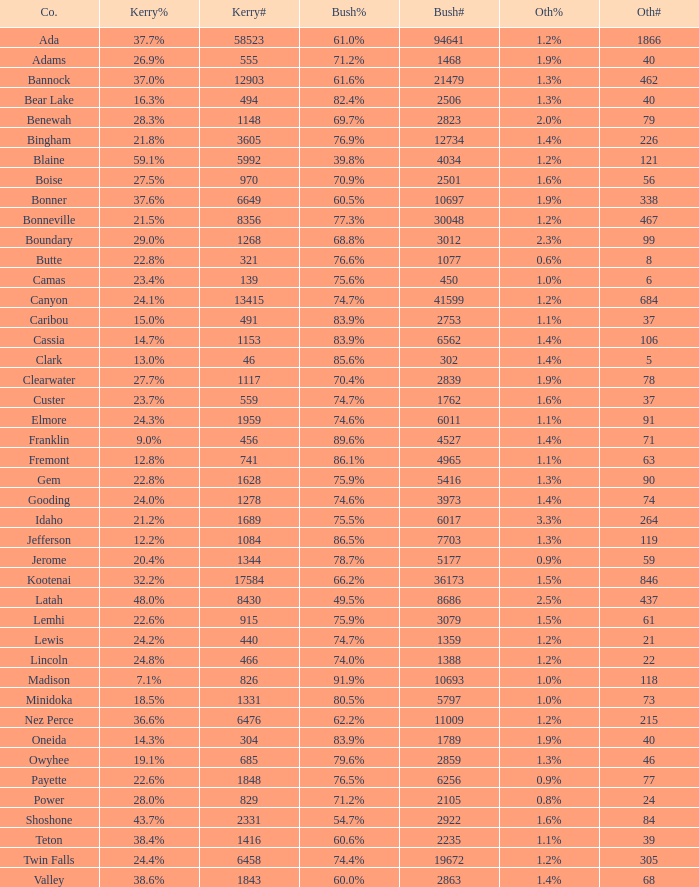What percentage of the people in Bonneville voted for Bush? 77.3%. 